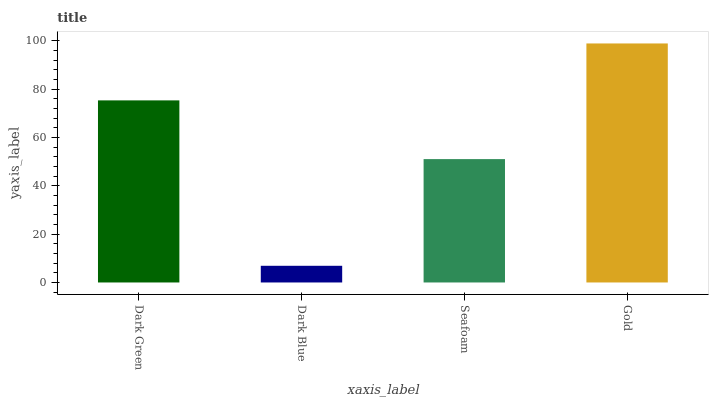Is Seafoam the minimum?
Answer yes or no. No. Is Seafoam the maximum?
Answer yes or no. No. Is Seafoam greater than Dark Blue?
Answer yes or no. Yes. Is Dark Blue less than Seafoam?
Answer yes or no. Yes. Is Dark Blue greater than Seafoam?
Answer yes or no. No. Is Seafoam less than Dark Blue?
Answer yes or no. No. Is Dark Green the high median?
Answer yes or no. Yes. Is Seafoam the low median?
Answer yes or no. Yes. Is Seafoam the high median?
Answer yes or no. No. Is Dark Blue the low median?
Answer yes or no. No. 